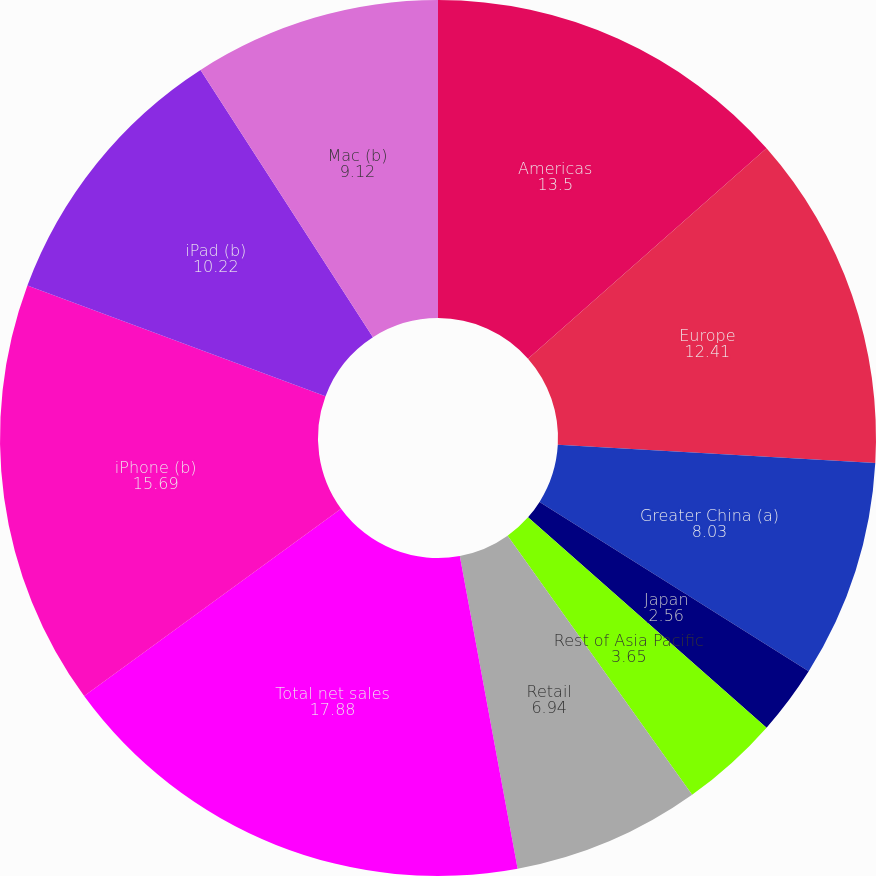Convert chart. <chart><loc_0><loc_0><loc_500><loc_500><pie_chart><fcel>Americas<fcel>Europe<fcel>Greater China (a)<fcel>Japan<fcel>Rest of Asia Pacific<fcel>Retail<fcel>Total net sales<fcel>iPhone (b)<fcel>iPad (b)<fcel>Mac (b)<nl><fcel>13.5%<fcel>12.41%<fcel>8.03%<fcel>2.56%<fcel>3.65%<fcel>6.94%<fcel>17.88%<fcel>15.69%<fcel>10.22%<fcel>9.12%<nl></chart> 